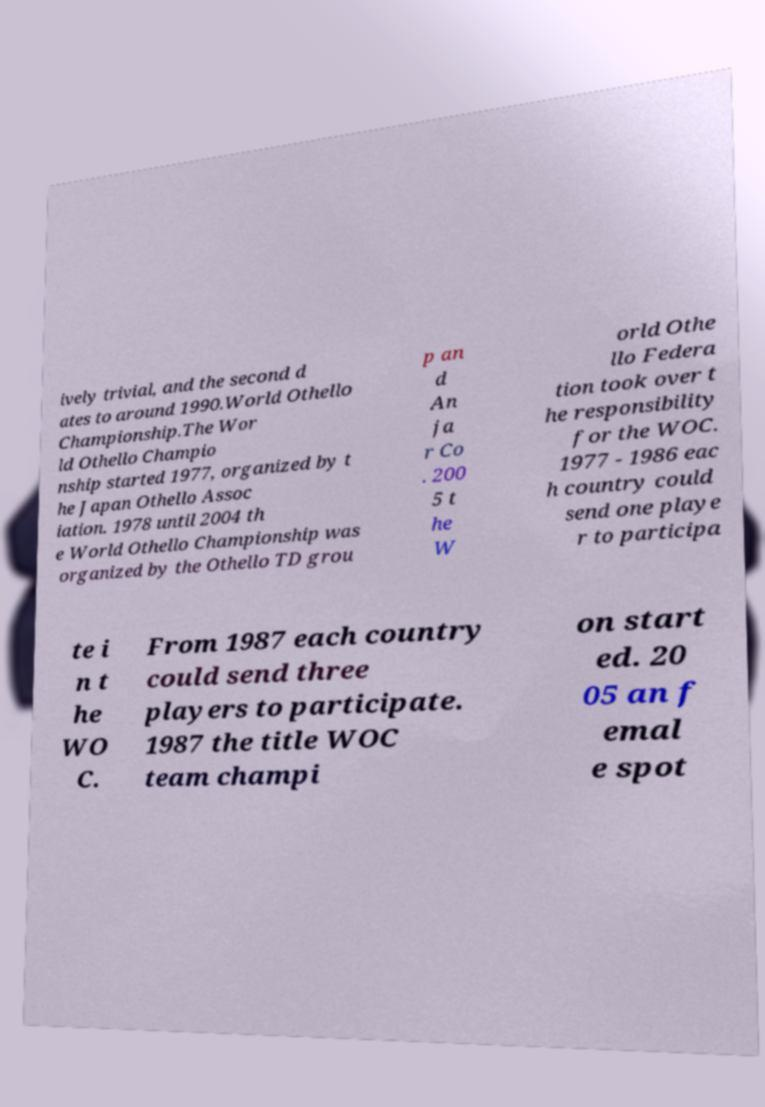For documentation purposes, I need the text within this image transcribed. Could you provide that? ively trivial, and the second d ates to around 1990.World Othello Championship.The Wor ld Othello Champio nship started 1977, organized by t he Japan Othello Assoc iation. 1978 until 2004 th e World Othello Championship was organized by the Othello TD grou p an d An ja r Co . 200 5 t he W orld Othe llo Federa tion took over t he responsibility for the WOC. 1977 - 1986 eac h country could send one playe r to participa te i n t he WO C. From 1987 each country could send three players to participate. 1987 the title WOC team champi on start ed. 20 05 an f emal e spot 